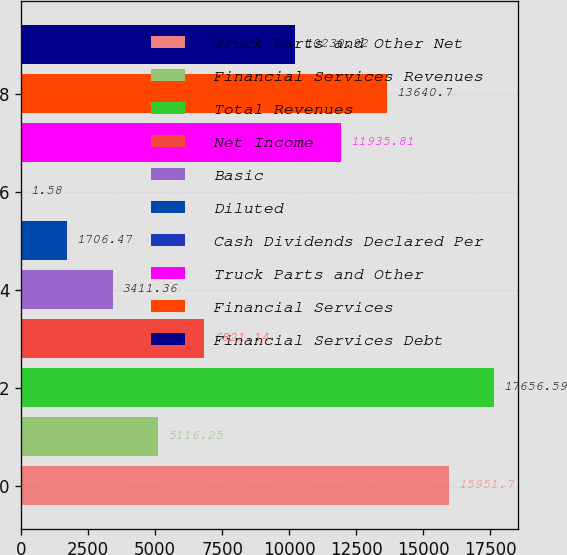<chart> <loc_0><loc_0><loc_500><loc_500><bar_chart><fcel>Truck Parts and Other Net<fcel>Financial Services Revenues<fcel>Total Revenues<fcel>Net Income<fcel>Basic<fcel>Diluted<fcel>Cash Dividends Declared Per<fcel>Truck Parts and Other<fcel>Financial Services<fcel>Financial Services Debt<nl><fcel>15951.7<fcel>5116.25<fcel>17656.6<fcel>6821.14<fcel>3411.36<fcel>1706.47<fcel>1.58<fcel>11935.8<fcel>13640.7<fcel>10230.9<nl></chart> 